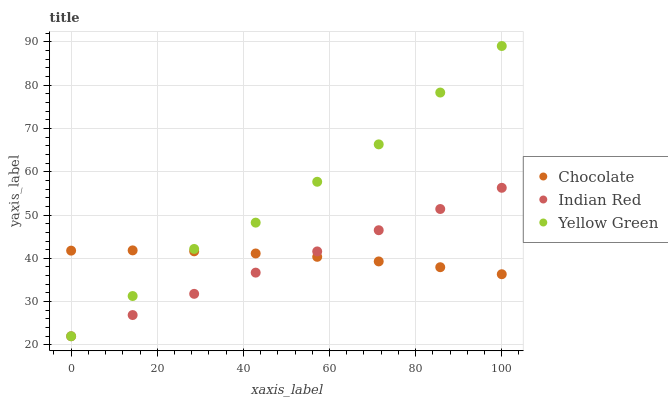Does Indian Red have the minimum area under the curve?
Answer yes or no. Yes. Does Yellow Green have the maximum area under the curve?
Answer yes or no. Yes. Does Chocolate have the minimum area under the curve?
Answer yes or no. No. Does Chocolate have the maximum area under the curve?
Answer yes or no. No. Is Indian Red the smoothest?
Answer yes or no. Yes. Is Yellow Green the roughest?
Answer yes or no. Yes. Is Chocolate the smoothest?
Answer yes or no. No. Is Chocolate the roughest?
Answer yes or no. No. Does Yellow Green have the lowest value?
Answer yes or no. Yes. Does Chocolate have the lowest value?
Answer yes or no. No. Does Yellow Green have the highest value?
Answer yes or no. Yes. Does Indian Red have the highest value?
Answer yes or no. No. Does Chocolate intersect Yellow Green?
Answer yes or no. Yes. Is Chocolate less than Yellow Green?
Answer yes or no. No. Is Chocolate greater than Yellow Green?
Answer yes or no. No. 